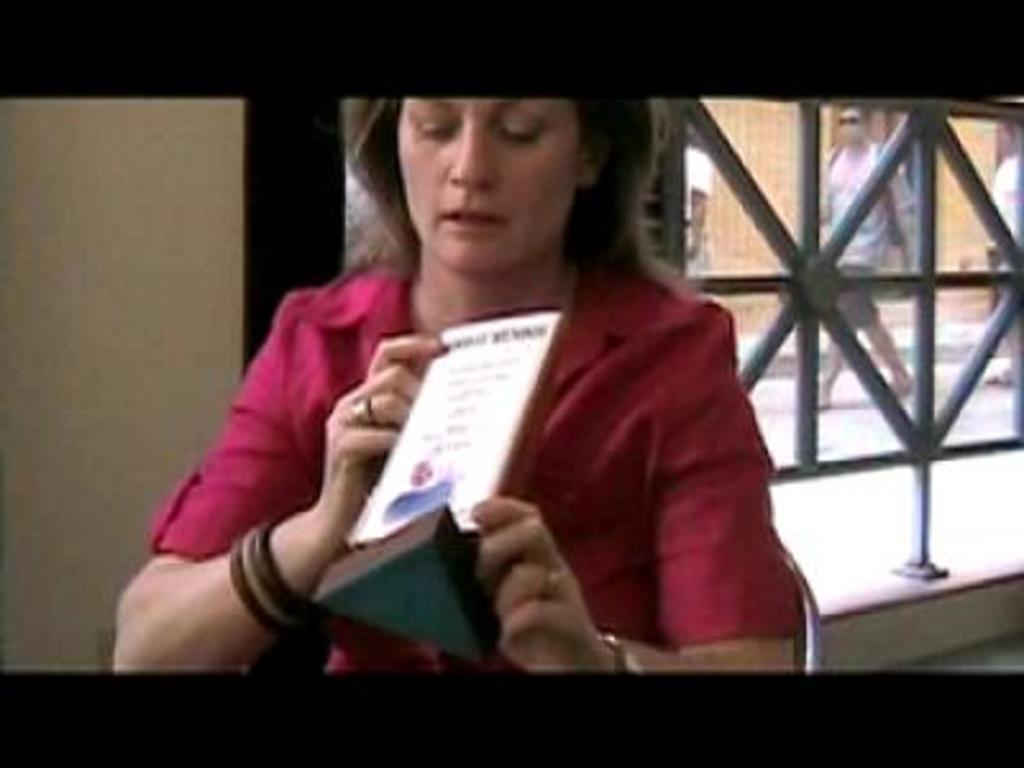Can you describe this image briefly? In this image there is a woman holding an object in her hand. She is sitting on a chair. Behind her there is a fence to the wall. Behind the fence there are few persons walking on the land. Behind them there is a wall. 